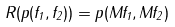Convert formula to latex. <formula><loc_0><loc_0><loc_500><loc_500>R ( p ( f _ { 1 } , f _ { 2 } ) ) = p ( M f _ { 1 } , M f _ { 2 } )</formula> 